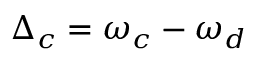<formula> <loc_0><loc_0><loc_500><loc_500>\Delta _ { c } = \omega _ { c } - \omega _ { d }</formula> 